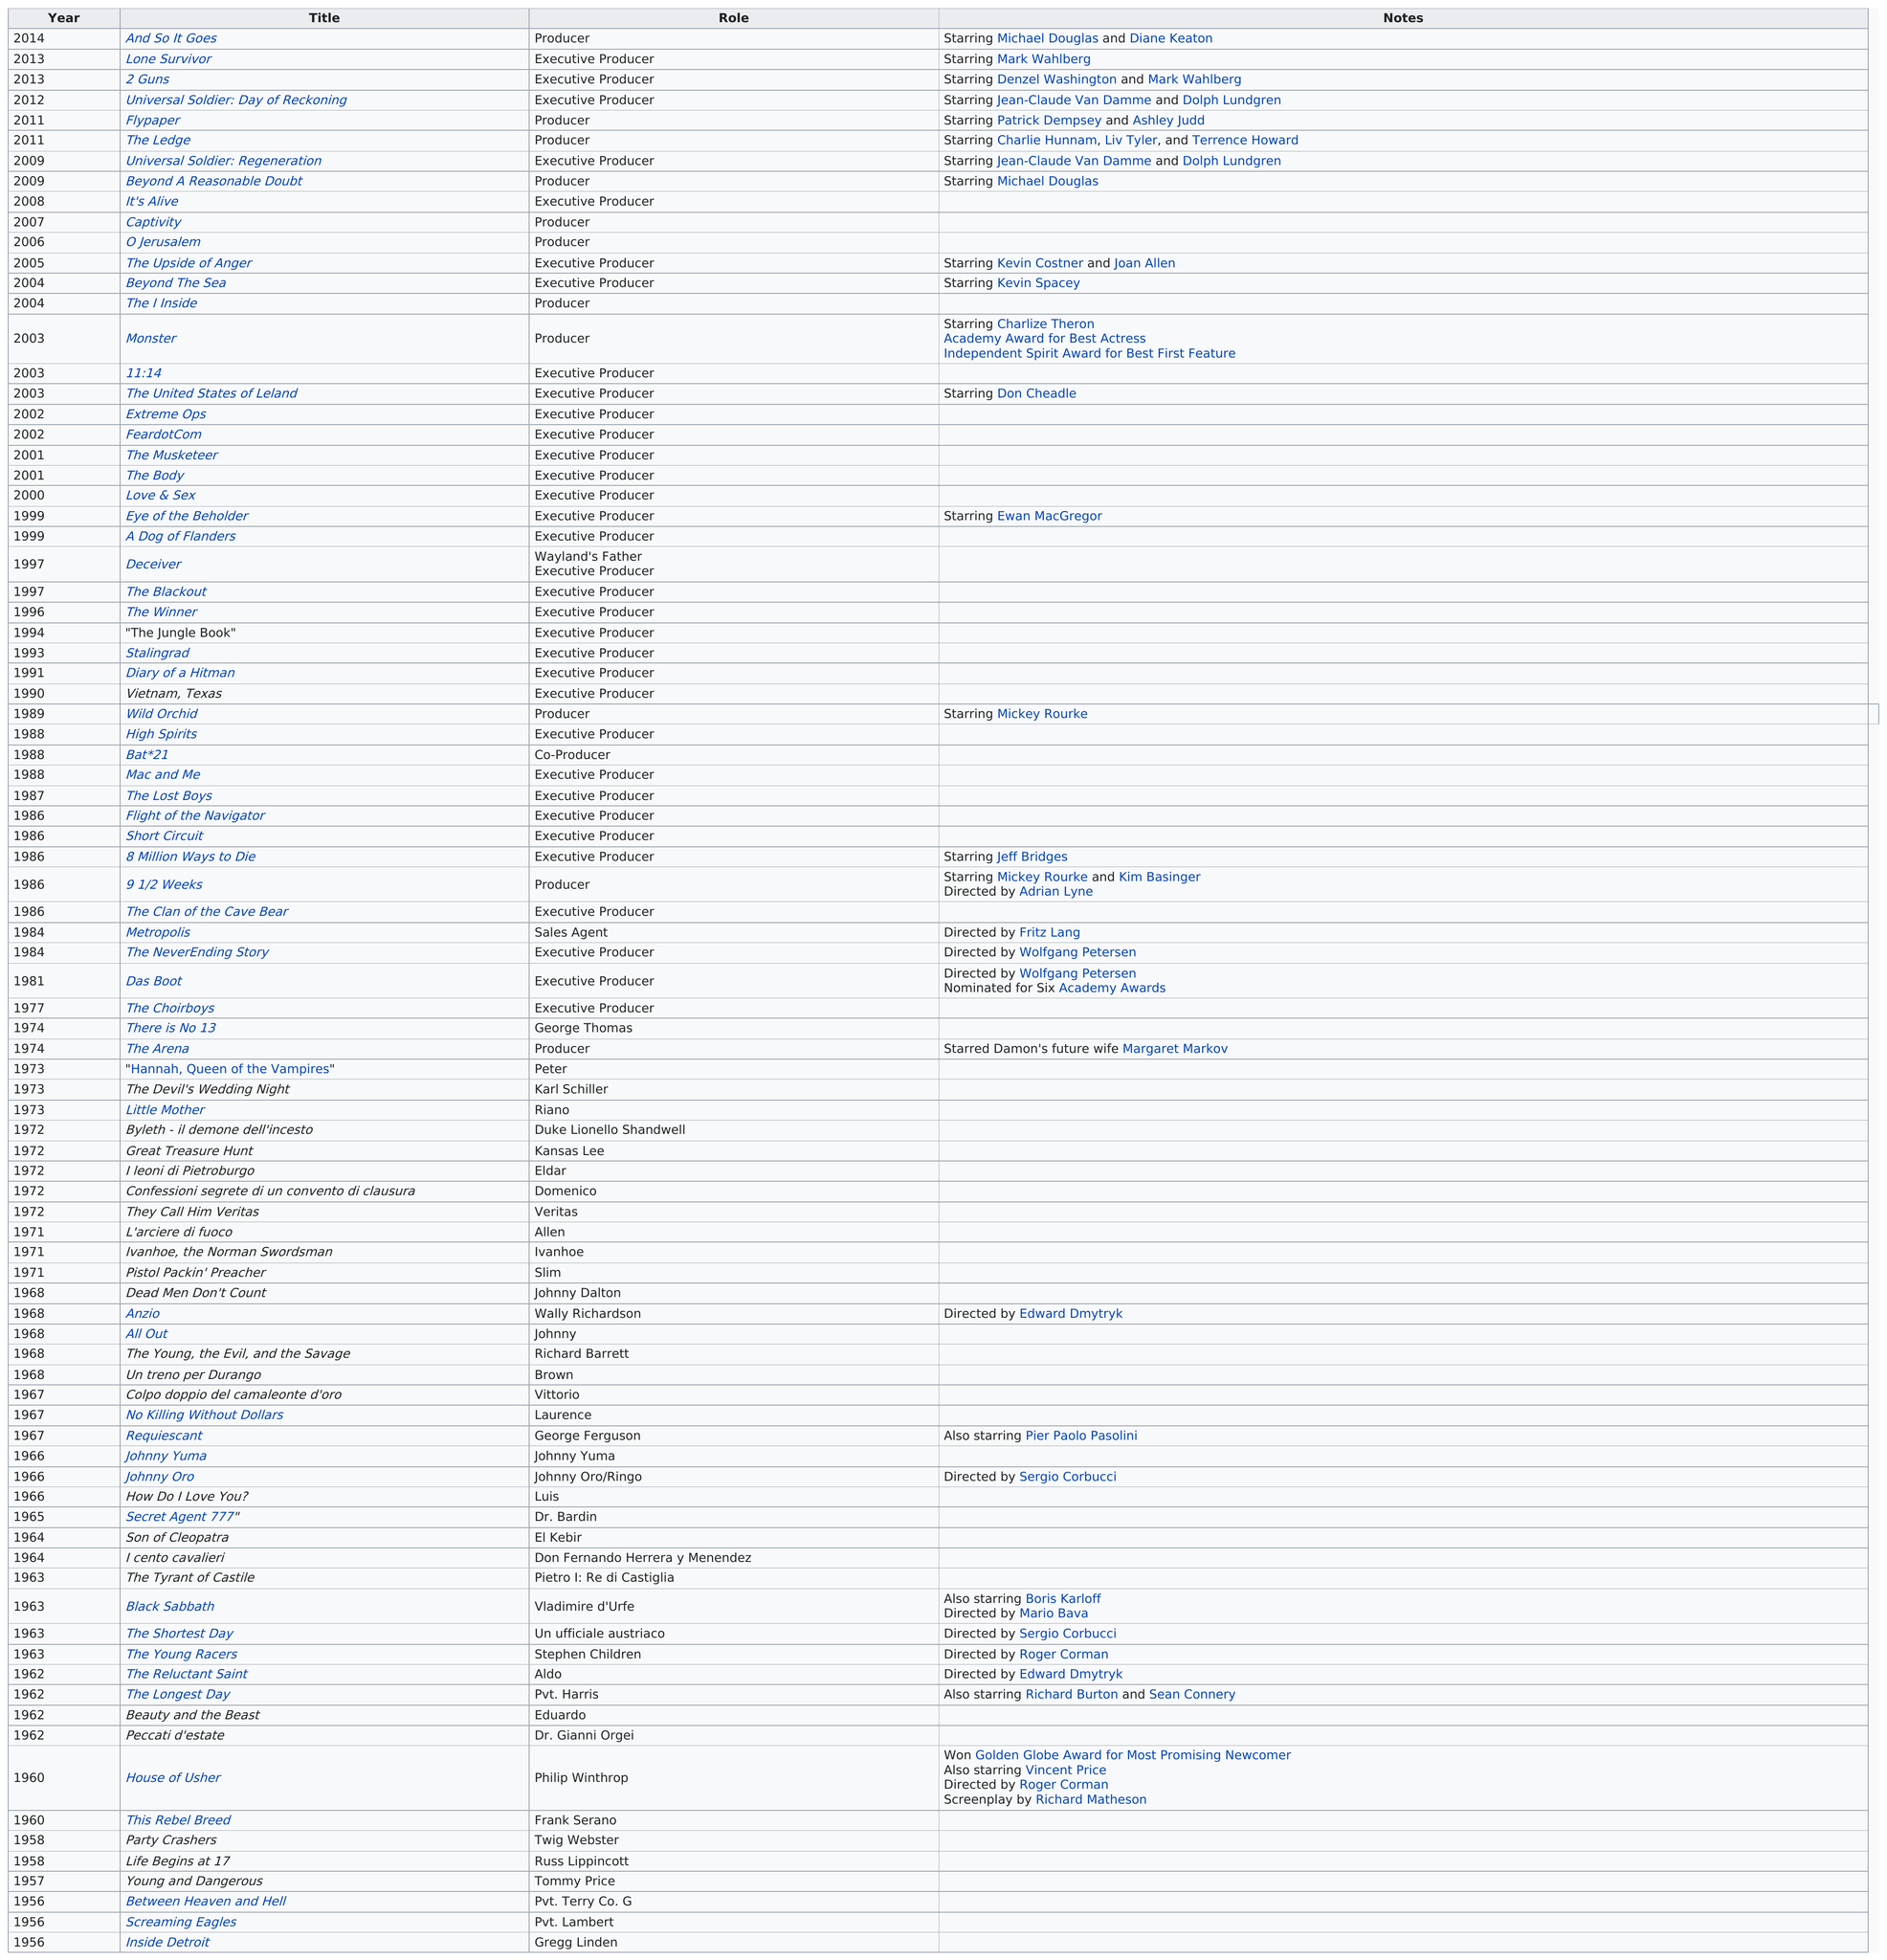Indicate a few pertinent items in this graphic. Damon executive produced a film that starred Kevin Costner and Joan Allen, which was titled The Upside of Anger. Damon's most award-winning title is 'Monster,' according to which he won the most awards. There are 32 instances in this chart where "executive producer" is listed as the role. The total number of times Dolph Lundgren starred in a title according to this list is 2. Of the titles that have also starred Michael Douglas, two of them have been identified. 